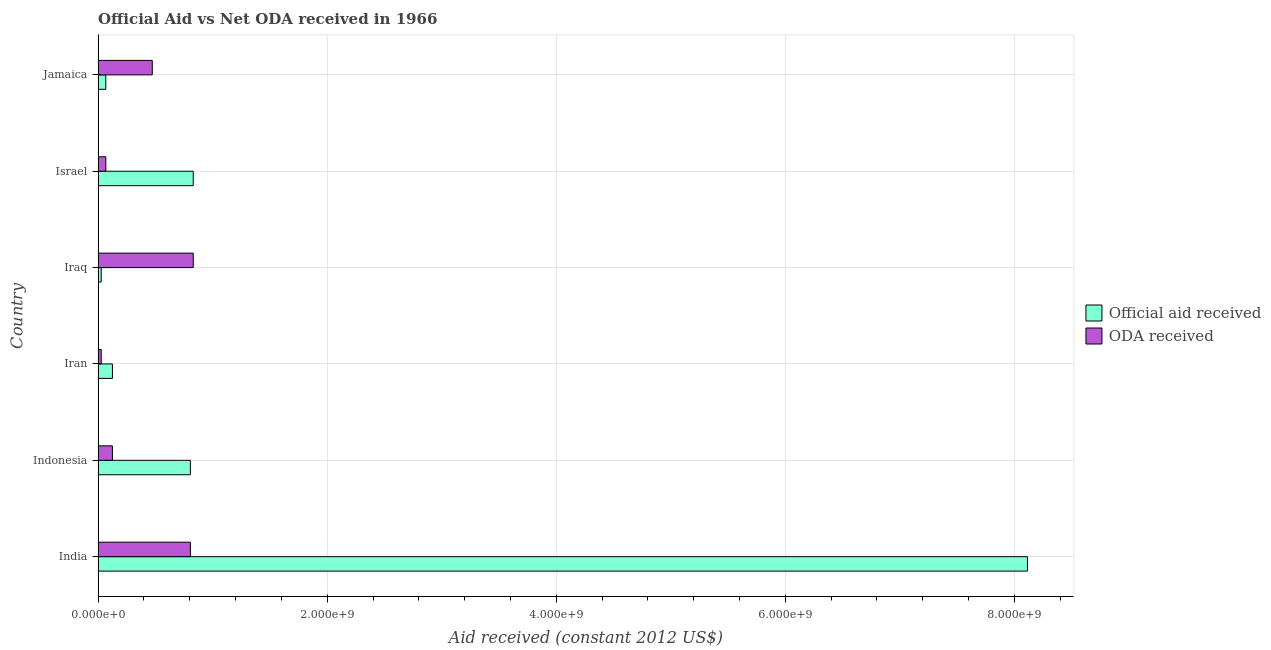Are the number of bars per tick equal to the number of legend labels?
Ensure brevity in your answer.  Yes. Are the number of bars on each tick of the Y-axis equal?
Your response must be concise. Yes. How many bars are there on the 1st tick from the top?
Your answer should be compact. 2. In how many cases, is the number of bars for a given country not equal to the number of legend labels?
Provide a short and direct response. 0. What is the official aid received in Iraq?
Your answer should be very brief. 2.70e+07. Across all countries, what is the maximum oda received?
Make the answer very short. 8.31e+08. Across all countries, what is the minimum official aid received?
Ensure brevity in your answer.  2.70e+07. In which country was the oda received maximum?
Provide a succinct answer. Iraq. In which country was the official aid received minimum?
Your answer should be very brief. Iraq. What is the total oda received in the graph?
Your answer should be compact. 2.33e+09. What is the difference between the official aid received in Iran and that in Jamaica?
Your answer should be very brief. 5.78e+07. What is the average oda received per country?
Offer a very short reply. 3.88e+08. What is the difference between the official aid received and oda received in Indonesia?
Ensure brevity in your answer.  6.81e+08. What is the ratio of the official aid received in India to that in Iran?
Provide a short and direct response. 64.97. Is the difference between the oda received in Indonesia and Jamaica greater than the difference between the official aid received in Indonesia and Jamaica?
Provide a short and direct response. No. What is the difference between the highest and the second highest official aid received?
Your response must be concise. 7.28e+09. What is the difference between the highest and the lowest official aid received?
Offer a very short reply. 8.09e+09. What does the 2nd bar from the top in Iran represents?
Give a very brief answer. Official aid received. What does the 1st bar from the bottom in Indonesia represents?
Your answer should be very brief. Official aid received. How many bars are there?
Offer a terse response. 12. Are all the bars in the graph horizontal?
Offer a very short reply. Yes. How many countries are there in the graph?
Provide a succinct answer. 6. Does the graph contain any zero values?
Make the answer very short. No. Does the graph contain grids?
Make the answer very short. Yes. Where does the legend appear in the graph?
Ensure brevity in your answer.  Center right. How are the legend labels stacked?
Provide a short and direct response. Vertical. What is the title of the graph?
Ensure brevity in your answer.  Official Aid vs Net ODA received in 1966 . What is the label or title of the X-axis?
Give a very brief answer. Aid received (constant 2012 US$). What is the Aid received (constant 2012 US$) of Official aid received in India?
Make the answer very short. 8.11e+09. What is the Aid received (constant 2012 US$) in ODA received in India?
Keep it short and to the point. 8.06e+08. What is the Aid received (constant 2012 US$) in Official aid received in Indonesia?
Offer a very short reply. 8.06e+08. What is the Aid received (constant 2012 US$) of ODA received in Indonesia?
Your answer should be very brief. 1.25e+08. What is the Aid received (constant 2012 US$) in Official aid received in Iran?
Offer a very short reply. 1.25e+08. What is the Aid received (constant 2012 US$) of ODA received in Iran?
Your answer should be compact. 2.70e+07. What is the Aid received (constant 2012 US$) of Official aid received in Iraq?
Ensure brevity in your answer.  2.70e+07. What is the Aid received (constant 2012 US$) in ODA received in Iraq?
Provide a succinct answer. 8.31e+08. What is the Aid received (constant 2012 US$) in Official aid received in Israel?
Offer a very short reply. 8.31e+08. What is the Aid received (constant 2012 US$) of ODA received in Israel?
Ensure brevity in your answer.  6.71e+07. What is the Aid received (constant 2012 US$) of Official aid received in Jamaica?
Provide a succinct answer. 6.71e+07. What is the Aid received (constant 2012 US$) in ODA received in Jamaica?
Your answer should be very brief. 4.73e+08. Across all countries, what is the maximum Aid received (constant 2012 US$) of Official aid received?
Your answer should be compact. 8.11e+09. Across all countries, what is the maximum Aid received (constant 2012 US$) in ODA received?
Offer a very short reply. 8.31e+08. Across all countries, what is the minimum Aid received (constant 2012 US$) in Official aid received?
Your response must be concise. 2.70e+07. Across all countries, what is the minimum Aid received (constant 2012 US$) in ODA received?
Your answer should be compact. 2.70e+07. What is the total Aid received (constant 2012 US$) in Official aid received in the graph?
Offer a very short reply. 9.97e+09. What is the total Aid received (constant 2012 US$) in ODA received in the graph?
Offer a very short reply. 2.33e+09. What is the difference between the Aid received (constant 2012 US$) in Official aid received in India and that in Indonesia?
Provide a succinct answer. 7.31e+09. What is the difference between the Aid received (constant 2012 US$) in ODA received in India and that in Indonesia?
Ensure brevity in your answer.  6.81e+08. What is the difference between the Aid received (constant 2012 US$) of Official aid received in India and that in Iran?
Offer a terse response. 7.99e+09. What is the difference between the Aid received (constant 2012 US$) in ODA received in India and that in Iran?
Offer a terse response. 7.79e+08. What is the difference between the Aid received (constant 2012 US$) in Official aid received in India and that in Iraq?
Provide a short and direct response. 8.09e+09. What is the difference between the Aid received (constant 2012 US$) in ODA received in India and that in Iraq?
Provide a short and direct response. -2.50e+07. What is the difference between the Aid received (constant 2012 US$) of Official aid received in India and that in Israel?
Keep it short and to the point. 7.28e+09. What is the difference between the Aid received (constant 2012 US$) in ODA received in India and that in Israel?
Provide a short and direct response. 7.38e+08. What is the difference between the Aid received (constant 2012 US$) of Official aid received in India and that in Jamaica?
Keep it short and to the point. 8.05e+09. What is the difference between the Aid received (constant 2012 US$) in ODA received in India and that in Jamaica?
Provide a short and direct response. 3.33e+08. What is the difference between the Aid received (constant 2012 US$) in Official aid received in Indonesia and that in Iran?
Provide a short and direct response. 6.81e+08. What is the difference between the Aid received (constant 2012 US$) of ODA received in Indonesia and that in Iran?
Your response must be concise. 9.79e+07. What is the difference between the Aid received (constant 2012 US$) in Official aid received in Indonesia and that in Iraq?
Your answer should be very brief. 7.79e+08. What is the difference between the Aid received (constant 2012 US$) in ODA received in Indonesia and that in Iraq?
Provide a short and direct response. -7.06e+08. What is the difference between the Aid received (constant 2012 US$) of Official aid received in Indonesia and that in Israel?
Give a very brief answer. -2.50e+07. What is the difference between the Aid received (constant 2012 US$) of ODA received in Indonesia and that in Israel?
Provide a succinct answer. 5.78e+07. What is the difference between the Aid received (constant 2012 US$) of Official aid received in Indonesia and that in Jamaica?
Ensure brevity in your answer.  7.38e+08. What is the difference between the Aid received (constant 2012 US$) of ODA received in Indonesia and that in Jamaica?
Your answer should be very brief. -3.48e+08. What is the difference between the Aid received (constant 2012 US$) in Official aid received in Iran and that in Iraq?
Offer a very short reply. 9.79e+07. What is the difference between the Aid received (constant 2012 US$) in ODA received in Iran and that in Iraq?
Offer a very short reply. -8.04e+08. What is the difference between the Aid received (constant 2012 US$) in Official aid received in Iran and that in Israel?
Offer a terse response. -7.06e+08. What is the difference between the Aid received (constant 2012 US$) in ODA received in Iran and that in Israel?
Make the answer very short. -4.02e+07. What is the difference between the Aid received (constant 2012 US$) of Official aid received in Iran and that in Jamaica?
Your response must be concise. 5.78e+07. What is the difference between the Aid received (constant 2012 US$) in ODA received in Iran and that in Jamaica?
Ensure brevity in your answer.  -4.46e+08. What is the difference between the Aid received (constant 2012 US$) in Official aid received in Iraq and that in Israel?
Your answer should be compact. -8.04e+08. What is the difference between the Aid received (constant 2012 US$) of ODA received in Iraq and that in Israel?
Your answer should be compact. 7.63e+08. What is the difference between the Aid received (constant 2012 US$) of Official aid received in Iraq and that in Jamaica?
Offer a very short reply. -4.02e+07. What is the difference between the Aid received (constant 2012 US$) of ODA received in Iraq and that in Jamaica?
Keep it short and to the point. 3.58e+08. What is the difference between the Aid received (constant 2012 US$) in Official aid received in Israel and that in Jamaica?
Provide a short and direct response. 7.63e+08. What is the difference between the Aid received (constant 2012 US$) in ODA received in Israel and that in Jamaica?
Give a very brief answer. -4.06e+08. What is the difference between the Aid received (constant 2012 US$) of Official aid received in India and the Aid received (constant 2012 US$) of ODA received in Indonesia?
Offer a terse response. 7.99e+09. What is the difference between the Aid received (constant 2012 US$) in Official aid received in India and the Aid received (constant 2012 US$) in ODA received in Iran?
Provide a succinct answer. 8.09e+09. What is the difference between the Aid received (constant 2012 US$) in Official aid received in India and the Aid received (constant 2012 US$) in ODA received in Iraq?
Your answer should be compact. 7.28e+09. What is the difference between the Aid received (constant 2012 US$) of Official aid received in India and the Aid received (constant 2012 US$) of ODA received in Israel?
Your answer should be compact. 8.05e+09. What is the difference between the Aid received (constant 2012 US$) in Official aid received in India and the Aid received (constant 2012 US$) in ODA received in Jamaica?
Give a very brief answer. 7.64e+09. What is the difference between the Aid received (constant 2012 US$) of Official aid received in Indonesia and the Aid received (constant 2012 US$) of ODA received in Iran?
Give a very brief answer. 7.79e+08. What is the difference between the Aid received (constant 2012 US$) of Official aid received in Indonesia and the Aid received (constant 2012 US$) of ODA received in Iraq?
Keep it short and to the point. -2.50e+07. What is the difference between the Aid received (constant 2012 US$) in Official aid received in Indonesia and the Aid received (constant 2012 US$) in ODA received in Israel?
Provide a short and direct response. 7.38e+08. What is the difference between the Aid received (constant 2012 US$) in Official aid received in Indonesia and the Aid received (constant 2012 US$) in ODA received in Jamaica?
Give a very brief answer. 3.33e+08. What is the difference between the Aid received (constant 2012 US$) of Official aid received in Iran and the Aid received (constant 2012 US$) of ODA received in Iraq?
Keep it short and to the point. -7.06e+08. What is the difference between the Aid received (constant 2012 US$) in Official aid received in Iran and the Aid received (constant 2012 US$) in ODA received in Israel?
Keep it short and to the point. 5.78e+07. What is the difference between the Aid received (constant 2012 US$) of Official aid received in Iran and the Aid received (constant 2012 US$) of ODA received in Jamaica?
Make the answer very short. -3.48e+08. What is the difference between the Aid received (constant 2012 US$) in Official aid received in Iraq and the Aid received (constant 2012 US$) in ODA received in Israel?
Provide a succinct answer. -4.02e+07. What is the difference between the Aid received (constant 2012 US$) in Official aid received in Iraq and the Aid received (constant 2012 US$) in ODA received in Jamaica?
Offer a very short reply. -4.46e+08. What is the difference between the Aid received (constant 2012 US$) in Official aid received in Israel and the Aid received (constant 2012 US$) in ODA received in Jamaica?
Your response must be concise. 3.58e+08. What is the average Aid received (constant 2012 US$) of Official aid received per country?
Offer a terse response. 1.66e+09. What is the average Aid received (constant 2012 US$) in ODA received per country?
Your response must be concise. 3.88e+08. What is the difference between the Aid received (constant 2012 US$) of Official aid received and Aid received (constant 2012 US$) of ODA received in India?
Offer a terse response. 7.31e+09. What is the difference between the Aid received (constant 2012 US$) of Official aid received and Aid received (constant 2012 US$) of ODA received in Indonesia?
Offer a terse response. 6.81e+08. What is the difference between the Aid received (constant 2012 US$) of Official aid received and Aid received (constant 2012 US$) of ODA received in Iran?
Your answer should be compact. 9.79e+07. What is the difference between the Aid received (constant 2012 US$) of Official aid received and Aid received (constant 2012 US$) of ODA received in Iraq?
Give a very brief answer. -8.04e+08. What is the difference between the Aid received (constant 2012 US$) in Official aid received and Aid received (constant 2012 US$) in ODA received in Israel?
Your response must be concise. 7.63e+08. What is the difference between the Aid received (constant 2012 US$) in Official aid received and Aid received (constant 2012 US$) in ODA received in Jamaica?
Ensure brevity in your answer.  -4.06e+08. What is the ratio of the Aid received (constant 2012 US$) in Official aid received in India to that in Indonesia?
Provide a succinct answer. 10.07. What is the ratio of the Aid received (constant 2012 US$) of ODA received in India to that in Indonesia?
Make the answer very short. 6.45. What is the ratio of the Aid received (constant 2012 US$) of Official aid received in India to that in Iran?
Your response must be concise. 64.97. What is the ratio of the Aid received (constant 2012 US$) of ODA received in India to that in Iran?
Provide a short and direct response. 29.87. What is the ratio of the Aid received (constant 2012 US$) in Official aid received in India to that in Iraq?
Provide a short and direct response. 300.86. What is the ratio of the Aid received (constant 2012 US$) in ODA received in India to that in Iraq?
Provide a short and direct response. 0.97. What is the ratio of the Aid received (constant 2012 US$) of Official aid received in India to that in Israel?
Your answer should be compact. 9.77. What is the ratio of the Aid received (constant 2012 US$) of ODA received in India to that in Israel?
Your answer should be compact. 12. What is the ratio of the Aid received (constant 2012 US$) of Official aid received in India to that in Jamaica?
Offer a terse response. 120.89. What is the ratio of the Aid received (constant 2012 US$) in ODA received in India to that in Jamaica?
Give a very brief answer. 1.7. What is the ratio of the Aid received (constant 2012 US$) of Official aid received in Indonesia to that in Iran?
Give a very brief answer. 6.45. What is the ratio of the Aid received (constant 2012 US$) in ODA received in Indonesia to that in Iran?
Make the answer very short. 4.63. What is the ratio of the Aid received (constant 2012 US$) of Official aid received in Indonesia to that in Iraq?
Give a very brief answer. 29.87. What is the ratio of the Aid received (constant 2012 US$) of ODA received in Indonesia to that in Iraq?
Make the answer very short. 0.15. What is the ratio of the Aid received (constant 2012 US$) of Official aid received in Indonesia to that in Israel?
Ensure brevity in your answer.  0.97. What is the ratio of the Aid received (constant 2012 US$) in ODA received in Indonesia to that in Israel?
Your answer should be very brief. 1.86. What is the ratio of the Aid received (constant 2012 US$) of Official aid received in Indonesia to that in Jamaica?
Offer a terse response. 12. What is the ratio of the Aid received (constant 2012 US$) of ODA received in Indonesia to that in Jamaica?
Make the answer very short. 0.26. What is the ratio of the Aid received (constant 2012 US$) of Official aid received in Iran to that in Iraq?
Your response must be concise. 4.63. What is the ratio of the Aid received (constant 2012 US$) in ODA received in Iran to that in Iraq?
Offer a very short reply. 0.03. What is the ratio of the Aid received (constant 2012 US$) in Official aid received in Iran to that in Israel?
Give a very brief answer. 0.15. What is the ratio of the Aid received (constant 2012 US$) in ODA received in Iran to that in Israel?
Make the answer very short. 0.4. What is the ratio of the Aid received (constant 2012 US$) of Official aid received in Iran to that in Jamaica?
Make the answer very short. 1.86. What is the ratio of the Aid received (constant 2012 US$) of ODA received in Iran to that in Jamaica?
Offer a very short reply. 0.06. What is the ratio of the Aid received (constant 2012 US$) in Official aid received in Iraq to that in Israel?
Ensure brevity in your answer.  0.03. What is the ratio of the Aid received (constant 2012 US$) of ODA received in Iraq to that in Israel?
Provide a succinct answer. 12.37. What is the ratio of the Aid received (constant 2012 US$) in Official aid received in Iraq to that in Jamaica?
Give a very brief answer. 0.4. What is the ratio of the Aid received (constant 2012 US$) of ODA received in Iraq to that in Jamaica?
Give a very brief answer. 1.76. What is the ratio of the Aid received (constant 2012 US$) in Official aid received in Israel to that in Jamaica?
Provide a short and direct response. 12.37. What is the ratio of the Aid received (constant 2012 US$) of ODA received in Israel to that in Jamaica?
Your response must be concise. 0.14. What is the difference between the highest and the second highest Aid received (constant 2012 US$) of Official aid received?
Offer a terse response. 7.28e+09. What is the difference between the highest and the second highest Aid received (constant 2012 US$) of ODA received?
Offer a terse response. 2.50e+07. What is the difference between the highest and the lowest Aid received (constant 2012 US$) in Official aid received?
Offer a very short reply. 8.09e+09. What is the difference between the highest and the lowest Aid received (constant 2012 US$) of ODA received?
Your response must be concise. 8.04e+08. 